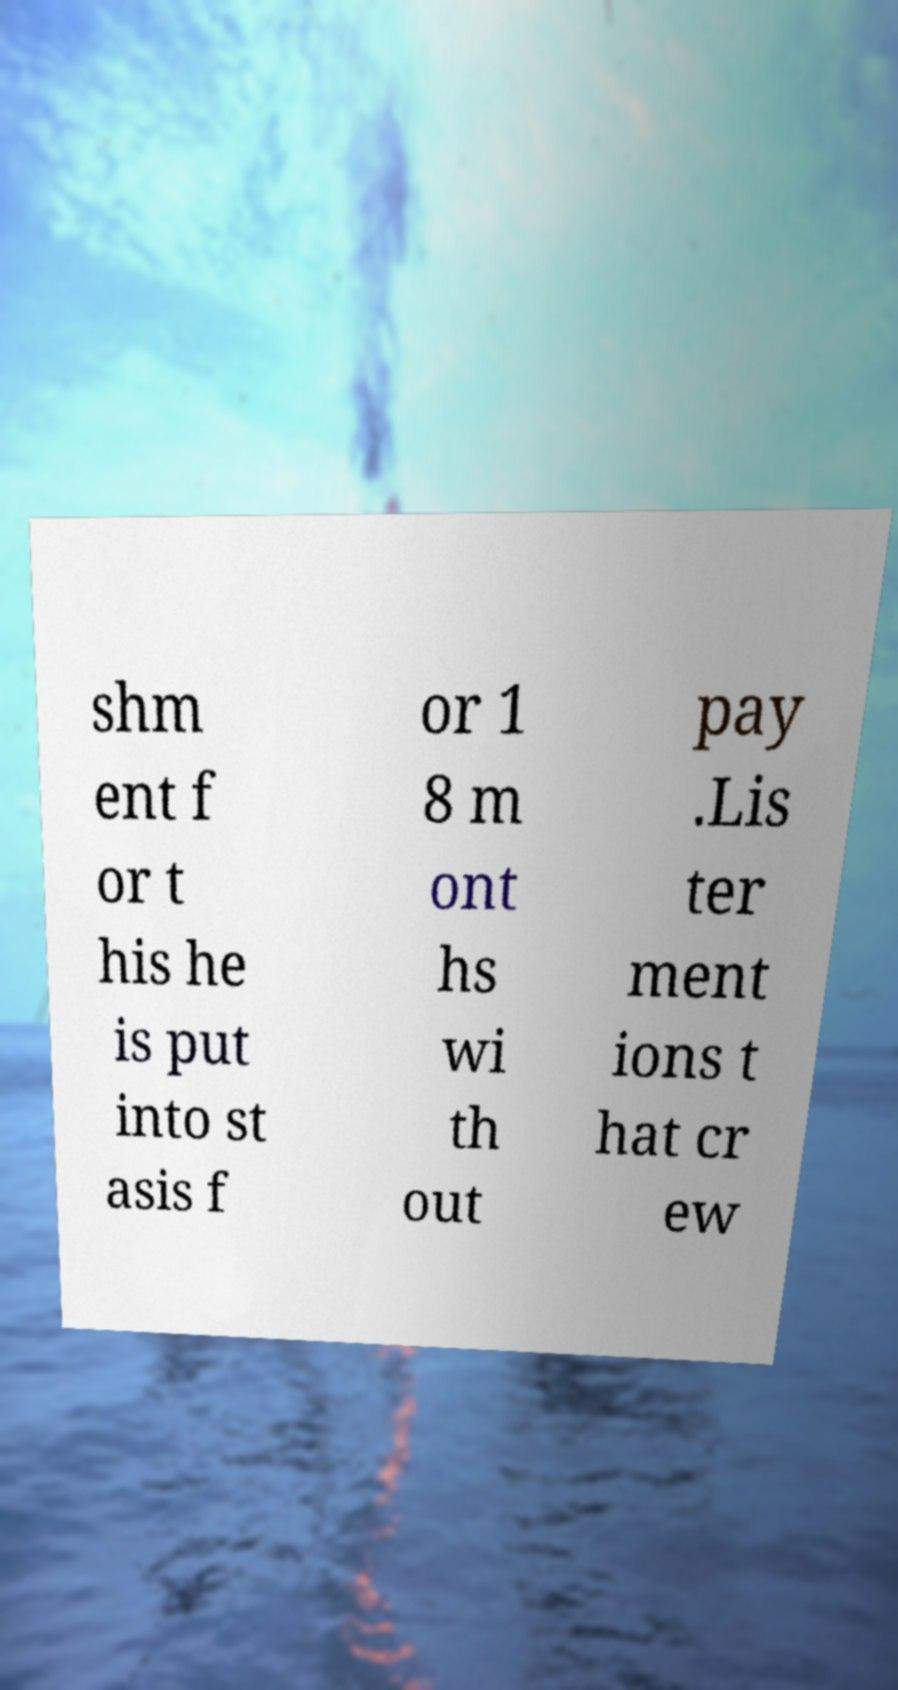Can you read and provide the text displayed in the image?This photo seems to have some interesting text. Can you extract and type it out for me? shm ent f or t his he is put into st asis f or 1 8 m ont hs wi th out pay .Lis ter ment ions t hat cr ew 